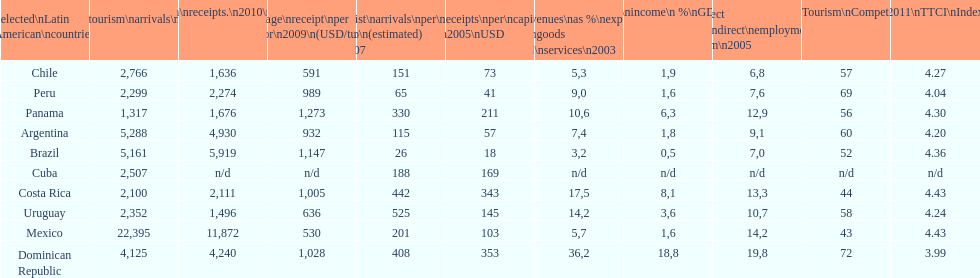How does brazil rank in average receipts per visitor in 2009? 1,147. 